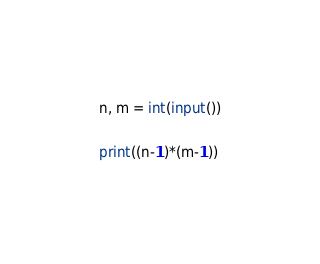<code> <loc_0><loc_0><loc_500><loc_500><_Python_>n, m = int(input())

print((n-1)*(m-1))</code> 